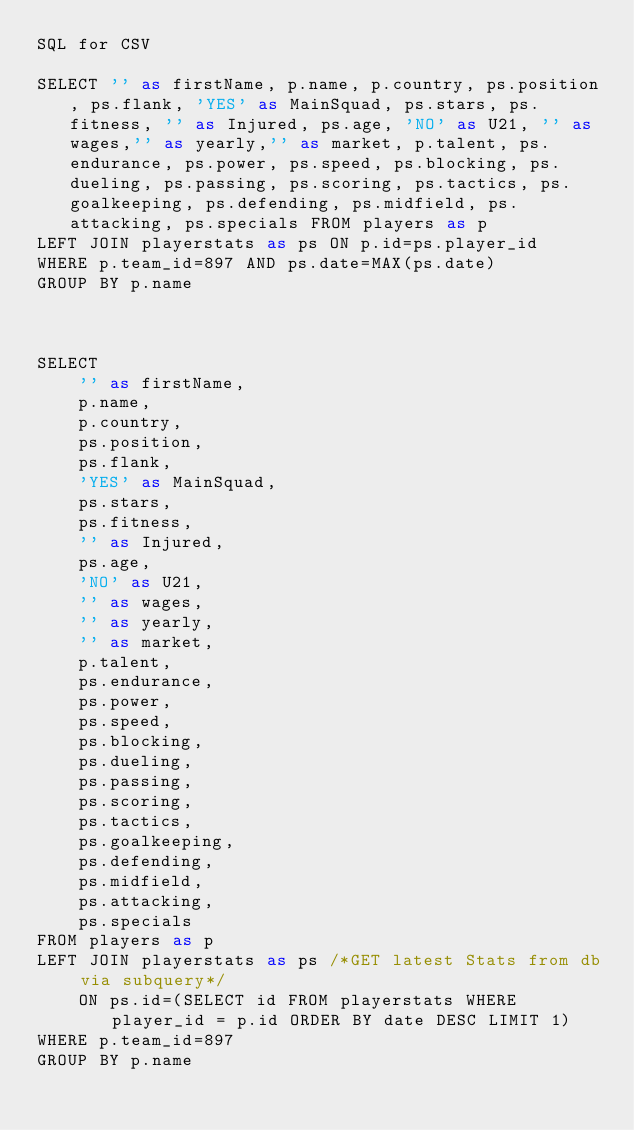Convert code to text. <code><loc_0><loc_0><loc_500><loc_500><_SQL_>SQL for CSV

SELECT '' as firstName, p.name, p.country, ps.position, ps.flank, 'YES' as MainSquad, ps.stars, ps.fitness, '' as Injured, ps.age, 'NO' as U21, '' as wages,'' as yearly,'' as market, p.talent, ps.endurance, ps.power, ps.speed, ps.blocking, ps.dueling, ps.passing, ps.scoring, ps.tactics, ps.goalkeeping, ps.defending, ps.midfield, ps.attacking, ps.specials FROM players as p 
LEFT JOIN playerstats as ps ON p.id=ps.player_id
WHERE p.team_id=897 AND ps.date=MAX(ps.date)
GROUP BY p.name



SELECT 
    '' as firstName, 
    p.name, 
    p.country, 
    ps.position, 
    ps.flank, 
    'YES' as MainSquad, 
    ps.stars, 
    ps.fitness, 
    '' as Injured, 
    ps.age, 
    'NO' as U21, 
    '' as wages,
    '' as yearly,
    '' as market, 
    p.talent, 
    ps.endurance, 
    ps.power, 
    ps.speed, 
    ps.blocking, 
    ps.dueling, 
    ps.passing, 
    ps.scoring, 
    ps.tactics, 
    ps.goalkeeping, 
    ps.defending, 
    ps.midfield, 
    ps.attacking, 
    ps.specials 
FROM players as p 
LEFT JOIN playerstats as ps /*GET latest Stats from db via subquery*/
    ON ps.id=(SELECT id FROM playerstats WHERE player_id = p.id ORDER BY date DESC LIMIT 1) 
WHERE p.team_id=897 
GROUP BY p.name</code> 